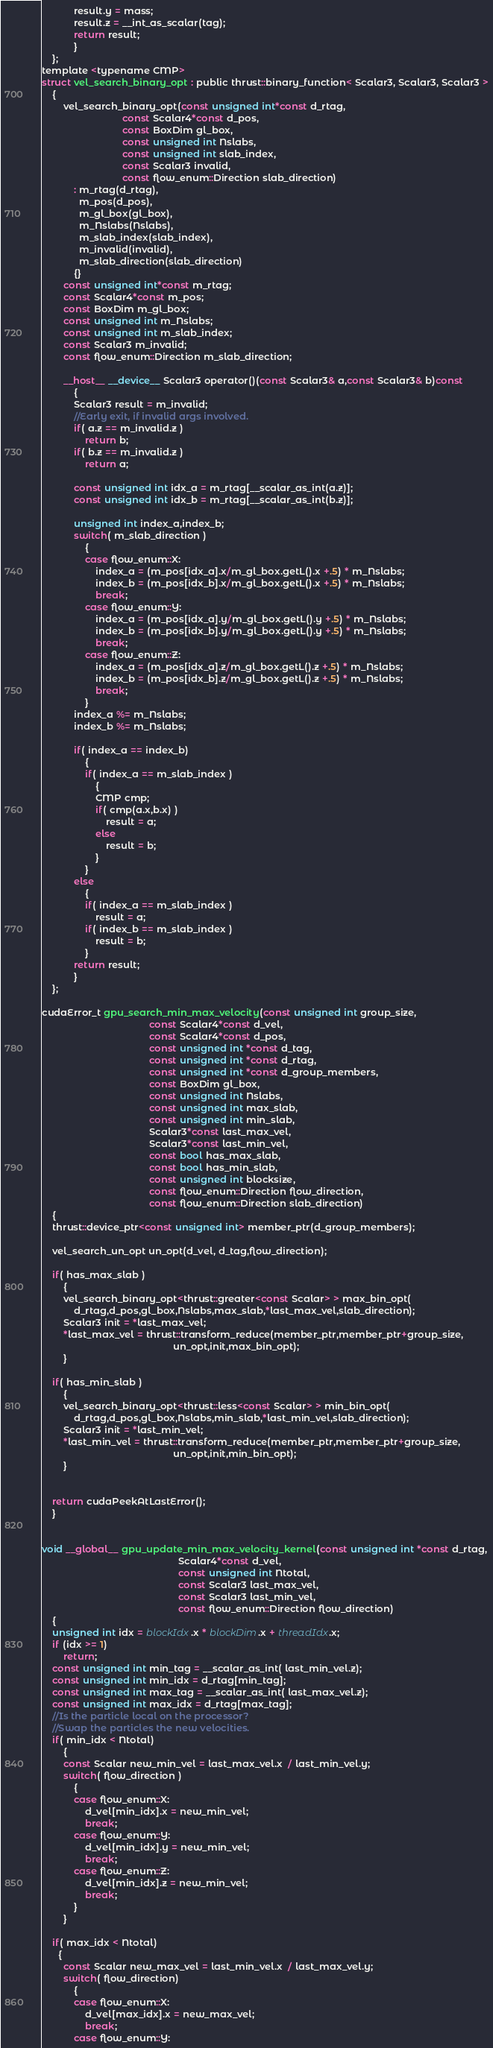<code> <loc_0><loc_0><loc_500><loc_500><_Cuda_>            result.y = mass;
            result.z = __int_as_scalar(tag);
            return result;
            }
    };
template <typename CMP>
struct vel_search_binary_opt : public thrust::binary_function< Scalar3, Scalar3, Scalar3 >
    {
        vel_search_binary_opt(const unsigned int*const d_rtag,
                              const Scalar4*const d_pos,
                              const BoxDim gl_box,
                              const unsigned int Nslabs,
                              const unsigned int slab_index,
                              const Scalar3 invalid,
                              const flow_enum::Direction slab_direction)
            : m_rtag(d_rtag),
              m_pos(d_pos),
              m_gl_box(gl_box),
              m_Nslabs(Nslabs),
              m_slab_index(slab_index),
              m_invalid(invalid),
              m_slab_direction(slab_direction)
            {}
        const unsigned int*const m_rtag;
        const Scalar4*const m_pos;
        const BoxDim m_gl_box;
        const unsigned int m_Nslabs;
        const unsigned int m_slab_index;
        const Scalar3 m_invalid;
        const flow_enum::Direction m_slab_direction;

        __host__ __device__ Scalar3 operator()(const Scalar3& a,const Scalar3& b)const
            {
            Scalar3 result = m_invalid;
            //Early exit, if invalid args involved.
            if( a.z == m_invalid.z )
                return b;
            if( b.z == m_invalid.z )
                return a;

            const unsigned int idx_a = m_rtag[__scalar_as_int(a.z)];
            const unsigned int idx_b = m_rtag[__scalar_as_int(b.z)];

            unsigned int index_a,index_b;
            switch( m_slab_direction )
                {
                case flow_enum::X:
                    index_a = (m_pos[idx_a].x/m_gl_box.getL().x +.5) * m_Nslabs;
                    index_b = (m_pos[idx_b].x/m_gl_box.getL().x +.5) * m_Nslabs;
                    break;
                case flow_enum::Y:
                    index_a = (m_pos[idx_a].y/m_gl_box.getL().y +.5) * m_Nslabs;
                    index_b = (m_pos[idx_b].y/m_gl_box.getL().y +.5) * m_Nslabs;
                    break;
                case flow_enum::Z:
                    index_a = (m_pos[idx_a].z/m_gl_box.getL().z +.5) * m_Nslabs;
                    index_b = (m_pos[idx_b].z/m_gl_box.getL().z +.5) * m_Nslabs;
                    break;
                }
            index_a %= m_Nslabs;
            index_b %= m_Nslabs;

            if( index_a == index_b)
                {
                if( index_a == m_slab_index )
                    {
                    CMP cmp;
                    if( cmp(a.x,b.x) )
                        result = a;
                    else
                        result = b;
                    }
                }
            else
                {
                if( index_a == m_slab_index )
                    result = a;
                if( index_b == m_slab_index )
                    result = b;
                }
            return result;
            }
    };

cudaError_t gpu_search_min_max_velocity(const unsigned int group_size,
                                        const Scalar4*const d_vel,
                                        const Scalar4*const d_pos,
                                        const unsigned int *const d_tag,
                                        const unsigned int *const d_rtag,
                                        const unsigned int *const d_group_members,
                                        const BoxDim gl_box,
                                        const unsigned int Nslabs,
                                        const unsigned int max_slab,
                                        const unsigned int min_slab,
                                        Scalar3*const last_max_vel,
                                        Scalar3*const last_min_vel,
                                        const bool has_max_slab,
                                        const bool has_min_slab,
                                        const unsigned int blocksize,
                                        const flow_enum::Direction flow_direction,
                                        const flow_enum::Direction slab_direction)
    {
    thrust::device_ptr<const unsigned int> member_ptr(d_group_members);

    vel_search_un_opt un_opt(d_vel, d_tag,flow_direction);

    if( has_max_slab )
        {
        vel_search_binary_opt<thrust::greater<const Scalar> > max_bin_opt(
            d_rtag,d_pos,gl_box,Nslabs,max_slab,*last_max_vel,slab_direction);
        Scalar3 init = *last_max_vel;
        *last_max_vel = thrust::transform_reduce(member_ptr,member_ptr+group_size,
                                                 un_opt,init,max_bin_opt);
        }

    if( has_min_slab )
        {
        vel_search_binary_opt<thrust::less<const Scalar> > min_bin_opt(
            d_rtag,d_pos,gl_box,Nslabs,min_slab,*last_min_vel,slab_direction);
        Scalar3 init = *last_min_vel;
        *last_min_vel = thrust::transform_reduce(member_ptr,member_ptr+group_size,
                                                 un_opt,init,min_bin_opt);
        }


    return cudaPeekAtLastError();
    }


void __global__ gpu_update_min_max_velocity_kernel(const unsigned int *const d_rtag,
                                                   Scalar4*const d_vel,
                                                   const unsigned int Ntotal,
                                                   const Scalar3 last_max_vel,
                                                   const Scalar3 last_min_vel,
                                                   const flow_enum::Direction flow_direction)
    {
    unsigned int idx = blockIdx.x * blockDim.x + threadIdx.x;
    if (idx >= 1)
        return;
    const unsigned int min_tag = __scalar_as_int( last_min_vel.z);
    const unsigned int min_idx = d_rtag[min_tag];
    const unsigned int max_tag = __scalar_as_int( last_max_vel.z);
    const unsigned int max_idx = d_rtag[max_tag];
    //Is the particle local on the processor?
    //Swap the particles the new velocities.
    if( min_idx < Ntotal)
        {
        const Scalar new_min_vel = last_max_vel.x  / last_min_vel.y;
        switch( flow_direction )
            {
            case flow_enum::X:
                d_vel[min_idx].x = new_min_vel;
                break;
            case flow_enum::Y:
                d_vel[min_idx].y = new_min_vel;
                break;
            case flow_enum::Z:
                d_vel[min_idx].z = new_min_vel;
                break;
            }
        }

    if( max_idx < Ntotal)
      {
        const Scalar new_max_vel = last_min_vel.x  / last_max_vel.y;
        switch( flow_direction)
            {
            case flow_enum::X:
                d_vel[max_idx].x = new_max_vel;
                break;
            case flow_enum::Y:</code> 